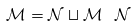Convert formula to latex. <formula><loc_0><loc_0><loc_500><loc_500>\mathcal { M } = \mathcal { N } \sqcup \mathcal { M } \ \mathcal { N }</formula> 